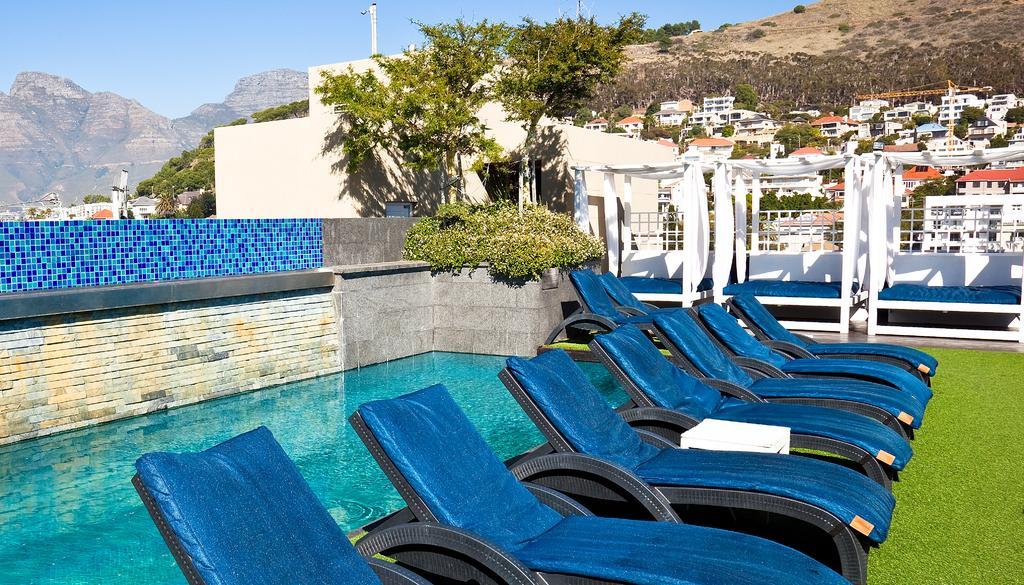In one or two sentences, can you explain what this image depicts? Here there are chairs on the grass and behind it we can see a swimming pool. In the background there are benches,white color clothes on the wooden poles,plants,trees,buildings,poles,mountains and sky. 